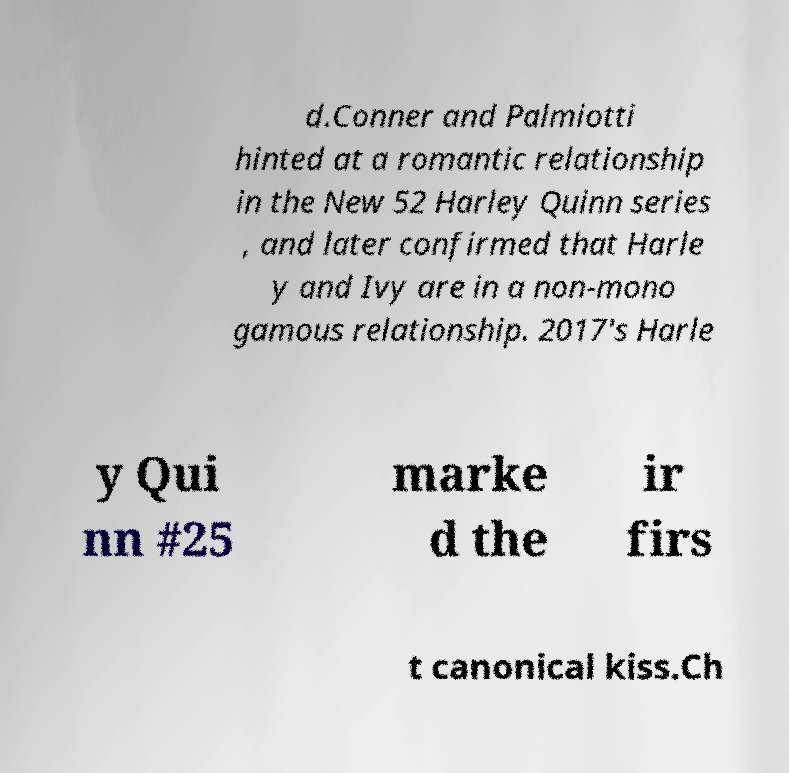What messages or text are displayed in this image? I need them in a readable, typed format. d.Conner and Palmiotti hinted at a romantic relationship in the New 52 Harley Quinn series , and later confirmed that Harle y and Ivy are in a non-mono gamous relationship. 2017's Harle y Qui nn #25 marke d the ir firs t canonical kiss.Ch 